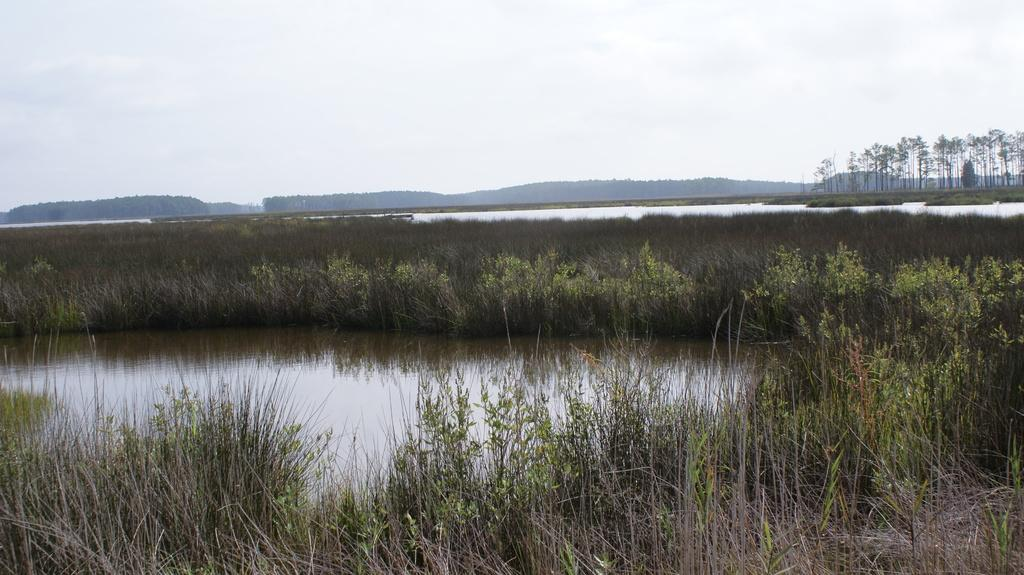What type of vegetation is present in the image? There is grass in the image. What natural feature is visible in the image? There is a water surface in the image. What can be seen in the background of the image? There are trees and the sky visible in the background of the image. Where is the drawer located in the image? There is no drawer present in the image. What type of joke can be seen in the image? There is no joke present in the image. 